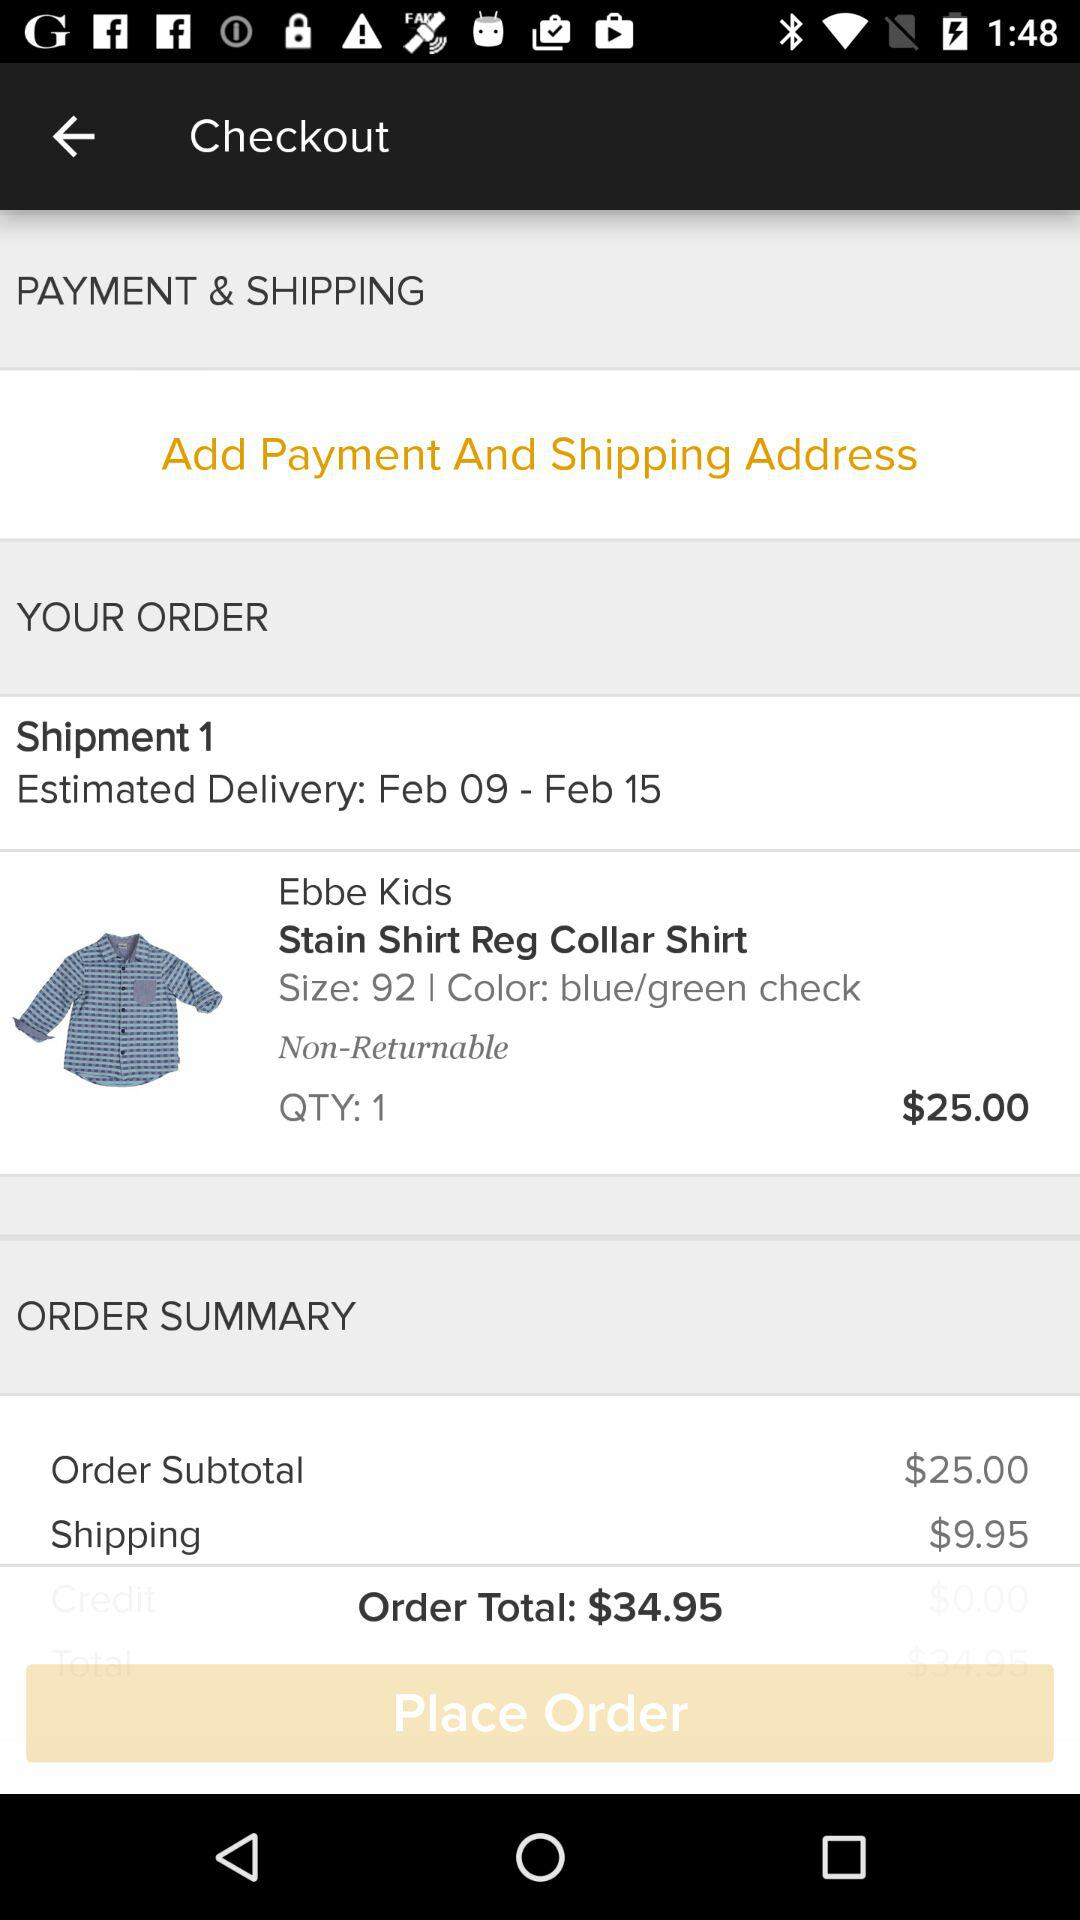How many items are in the order?
Answer the question using a single word or phrase. 1 